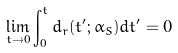<formula> <loc_0><loc_0><loc_500><loc_500>\lim _ { t \to 0 } \int _ { 0 } ^ { t } d _ { r } ( t ^ { \prime } ; \alpha _ { S } ) d t ^ { \prime } = 0</formula> 